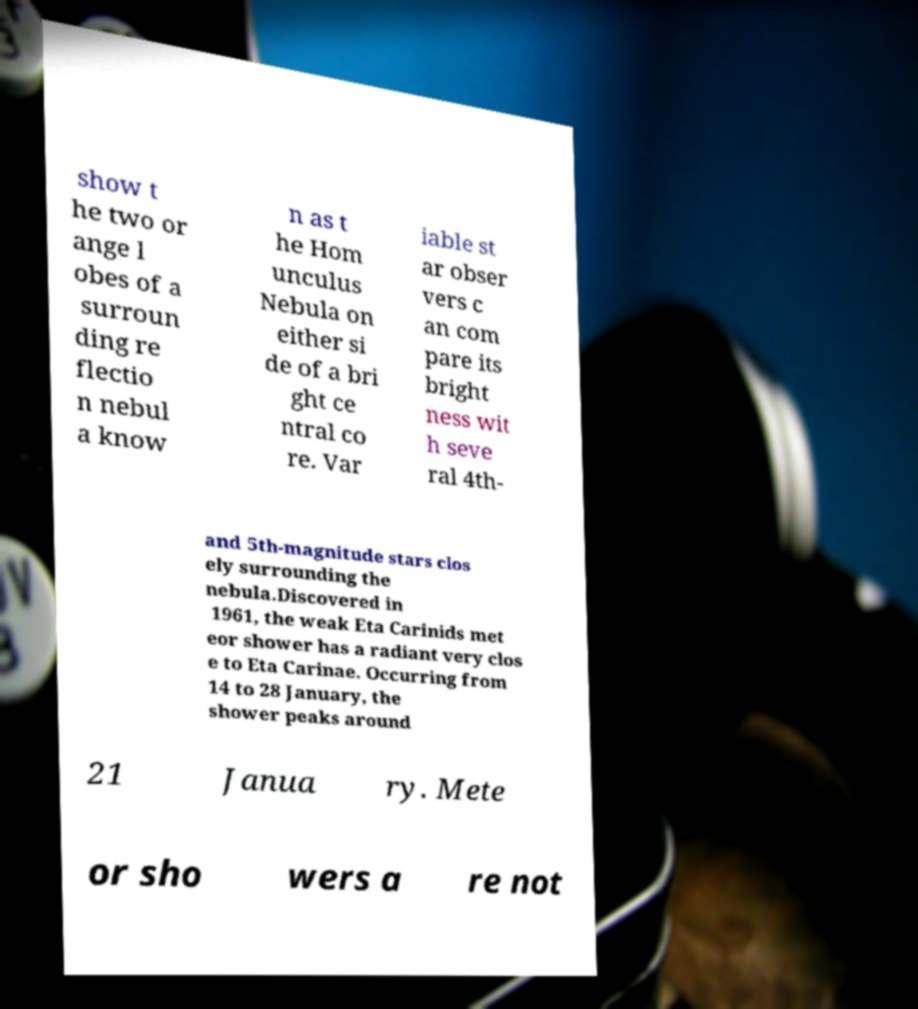Please identify and transcribe the text found in this image. show t he two or ange l obes of a surroun ding re flectio n nebul a know n as t he Hom unculus Nebula on either si de of a bri ght ce ntral co re. Var iable st ar obser vers c an com pare its bright ness wit h seve ral 4th- and 5th-magnitude stars clos ely surrounding the nebula.Discovered in 1961, the weak Eta Carinids met eor shower has a radiant very clos e to Eta Carinae. Occurring from 14 to 28 January, the shower peaks around 21 Janua ry. Mete or sho wers a re not 